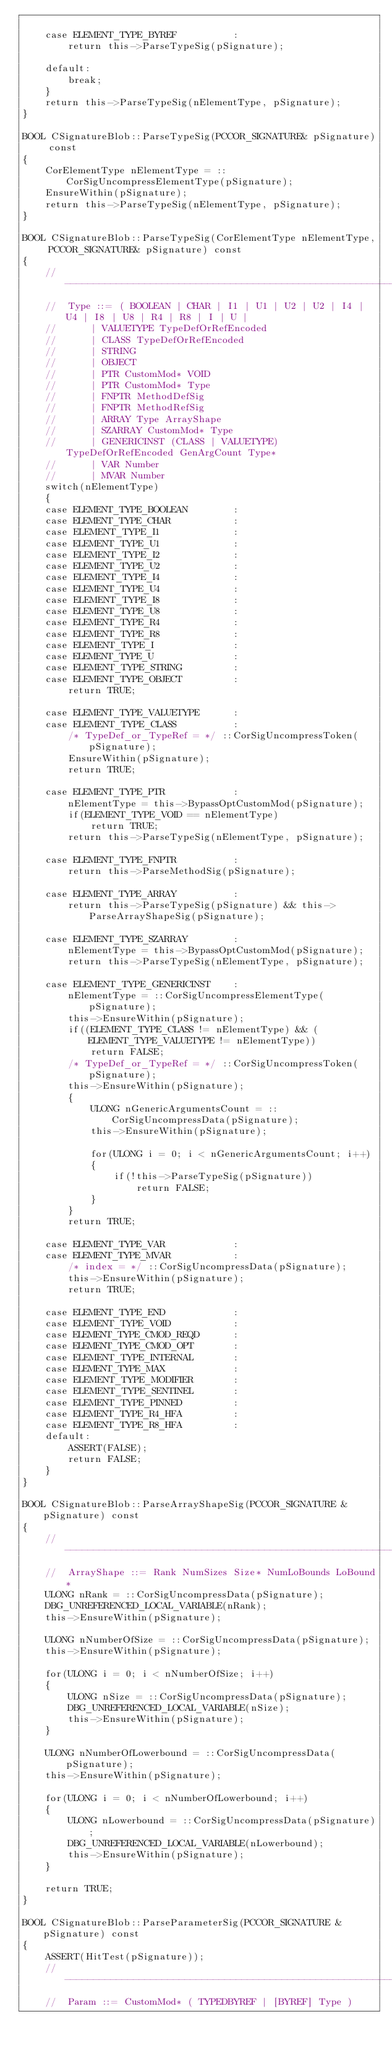<code> <loc_0><loc_0><loc_500><loc_500><_C++_>
    case ELEMENT_TYPE_BYREF          :
        return this->ParseTypeSig(pSignature);

    default:
        break;
    }
    return this->ParseTypeSig(nElementType, pSignature);
}

BOOL CSignatureBlob::ParseTypeSig(PCCOR_SIGNATURE& pSignature) const
{
    CorElementType nElementType = ::CorSigUncompressElementType(pSignature);
    EnsureWithin(pSignature);
    return this->ParseTypeSig(nElementType, pSignature);
}

BOOL CSignatureBlob::ParseTypeSig(CorElementType nElementType, PCCOR_SIGNATURE& pSignature) const
{
    //-----------------------------------------------------------------------------------
    //  Type ::= ( BOOLEAN | CHAR | I1 | U1 | U2 | U2 | I4 | U4 | I8 | U8 | R4 | R8 | I | U |
    //      | VALUETYPE TypeDefOrRefEncoded
    //      | CLASS TypeDefOrRefEncoded
    //      | STRING 
    //      | OBJECT
    //      | PTR CustomMod* VOID
    //      | PTR CustomMod* Type
    //      | FNPTR MethodDefSig
    //      | FNPTR MethodRefSig
    //      | ARRAY Type ArrayShape
    //      | SZARRAY CustomMod* Type
    //      | GENERICINST (CLASS | VALUETYPE) TypeDefOrRefEncoded GenArgCount Type*
    //      | VAR Number
    //      | MVAR Number
    switch(nElementType)
    {
    case ELEMENT_TYPE_BOOLEAN        :
    case ELEMENT_TYPE_CHAR           :
    case ELEMENT_TYPE_I1             :
    case ELEMENT_TYPE_U1             :
    case ELEMENT_TYPE_I2             :
    case ELEMENT_TYPE_U2             :
    case ELEMENT_TYPE_I4             :
    case ELEMENT_TYPE_U4             :
    case ELEMENT_TYPE_I8             :
    case ELEMENT_TYPE_U8             :
    case ELEMENT_TYPE_R4             :
    case ELEMENT_TYPE_R8             :
    case ELEMENT_TYPE_I              :
    case ELEMENT_TYPE_U              :
    case ELEMENT_TYPE_STRING         :
    case ELEMENT_TYPE_OBJECT         :
        return TRUE;

    case ELEMENT_TYPE_VALUETYPE      :
    case ELEMENT_TYPE_CLASS          :
        /* TypeDef_or_TypeRef = */ ::CorSigUncompressToken(pSignature);
        EnsureWithin(pSignature);
        return TRUE;

    case ELEMENT_TYPE_PTR            :
        nElementType = this->BypassOptCustomMod(pSignature);
        if(ELEMENT_TYPE_VOID == nElementType)
            return TRUE;
        return this->ParseTypeSig(nElementType, pSignature);

    case ELEMENT_TYPE_FNPTR          :
        return this->ParseMethodSig(pSignature);

    case ELEMENT_TYPE_ARRAY          :
        return this->ParseTypeSig(pSignature) && this->ParseArrayShapeSig(pSignature);

    case ELEMENT_TYPE_SZARRAY        :
        nElementType = this->BypassOptCustomMod(pSignature);
        return this->ParseTypeSig(nElementType, pSignature);

    case ELEMENT_TYPE_GENERICINST    :
        nElementType = ::CorSigUncompressElementType(pSignature);
        this->EnsureWithin(pSignature);
        if((ELEMENT_TYPE_CLASS != nElementType) && (ELEMENT_TYPE_VALUETYPE != nElementType))
            return FALSE;
        /* TypeDef_or_TypeRef = */ ::CorSigUncompressToken(pSignature);
        this->EnsureWithin(pSignature);
        {
            ULONG nGenericArgumentsCount = ::CorSigUncompressData(pSignature);
            this->EnsureWithin(pSignature);

            for(ULONG i = 0; i < nGenericArgumentsCount; i++)
            {
                if(!this->ParseTypeSig(pSignature))
                    return FALSE;
            }
        }
        return TRUE;

    case ELEMENT_TYPE_VAR            :
    case ELEMENT_TYPE_MVAR           :
        /* index = */ ::CorSigUncompressData(pSignature);
        this->EnsureWithin(pSignature);
        return TRUE;

    case ELEMENT_TYPE_END            :
    case ELEMENT_TYPE_VOID           :
    case ELEMENT_TYPE_CMOD_REQD      :
    case ELEMENT_TYPE_CMOD_OPT       :
    case ELEMENT_TYPE_INTERNAL       :
    case ELEMENT_TYPE_MAX            :
    case ELEMENT_TYPE_MODIFIER       :
    case ELEMENT_TYPE_SENTINEL       :
    case ELEMENT_TYPE_PINNED         :
    case ELEMENT_TYPE_R4_HFA         :
    case ELEMENT_TYPE_R8_HFA         :
    default:
        ASSERT(FALSE);
        return FALSE;
    }
}

BOOL CSignatureBlob::ParseArrayShapeSig(PCCOR_SIGNATURE &pSignature) const
{
    //-----------------------------------------------------------------------------------
    //  ArrayShape ::= Rank NumSizes Size* NumLoBounds LoBound*
    ULONG nRank = ::CorSigUncompressData(pSignature);
    DBG_UNREFERENCED_LOCAL_VARIABLE(nRank);
    this->EnsureWithin(pSignature);
    
    ULONG nNumberOfSize = ::CorSigUncompressData(pSignature);
    this->EnsureWithin(pSignature);
    
    for(ULONG i = 0; i < nNumberOfSize; i++)
    {
        ULONG nSize = ::CorSigUncompressData(pSignature);
        DBG_UNREFERENCED_LOCAL_VARIABLE(nSize);
        this->EnsureWithin(pSignature);
    }

    ULONG nNumberOfLowerbound = ::CorSigUncompressData(pSignature);
    this->EnsureWithin(pSignature);

    for(ULONG i = 0; i < nNumberOfLowerbound; i++)
    {
        ULONG nLowerbound = ::CorSigUncompressData(pSignature);
        DBG_UNREFERENCED_LOCAL_VARIABLE(nLowerbound);
        this->EnsureWithin(pSignature);
    }

    return TRUE;
}

BOOL CSignatureBlob::ParseParameterSig(PCCOR_SIGNATURE &pSignature) const
{
    ASSERT(HitTest(pSignature));
    //-----------------------------------------------------------------------------------
    //  Param ::= CustomMod* ( TYPEDBYREF | [BYREF] Type )</code> 